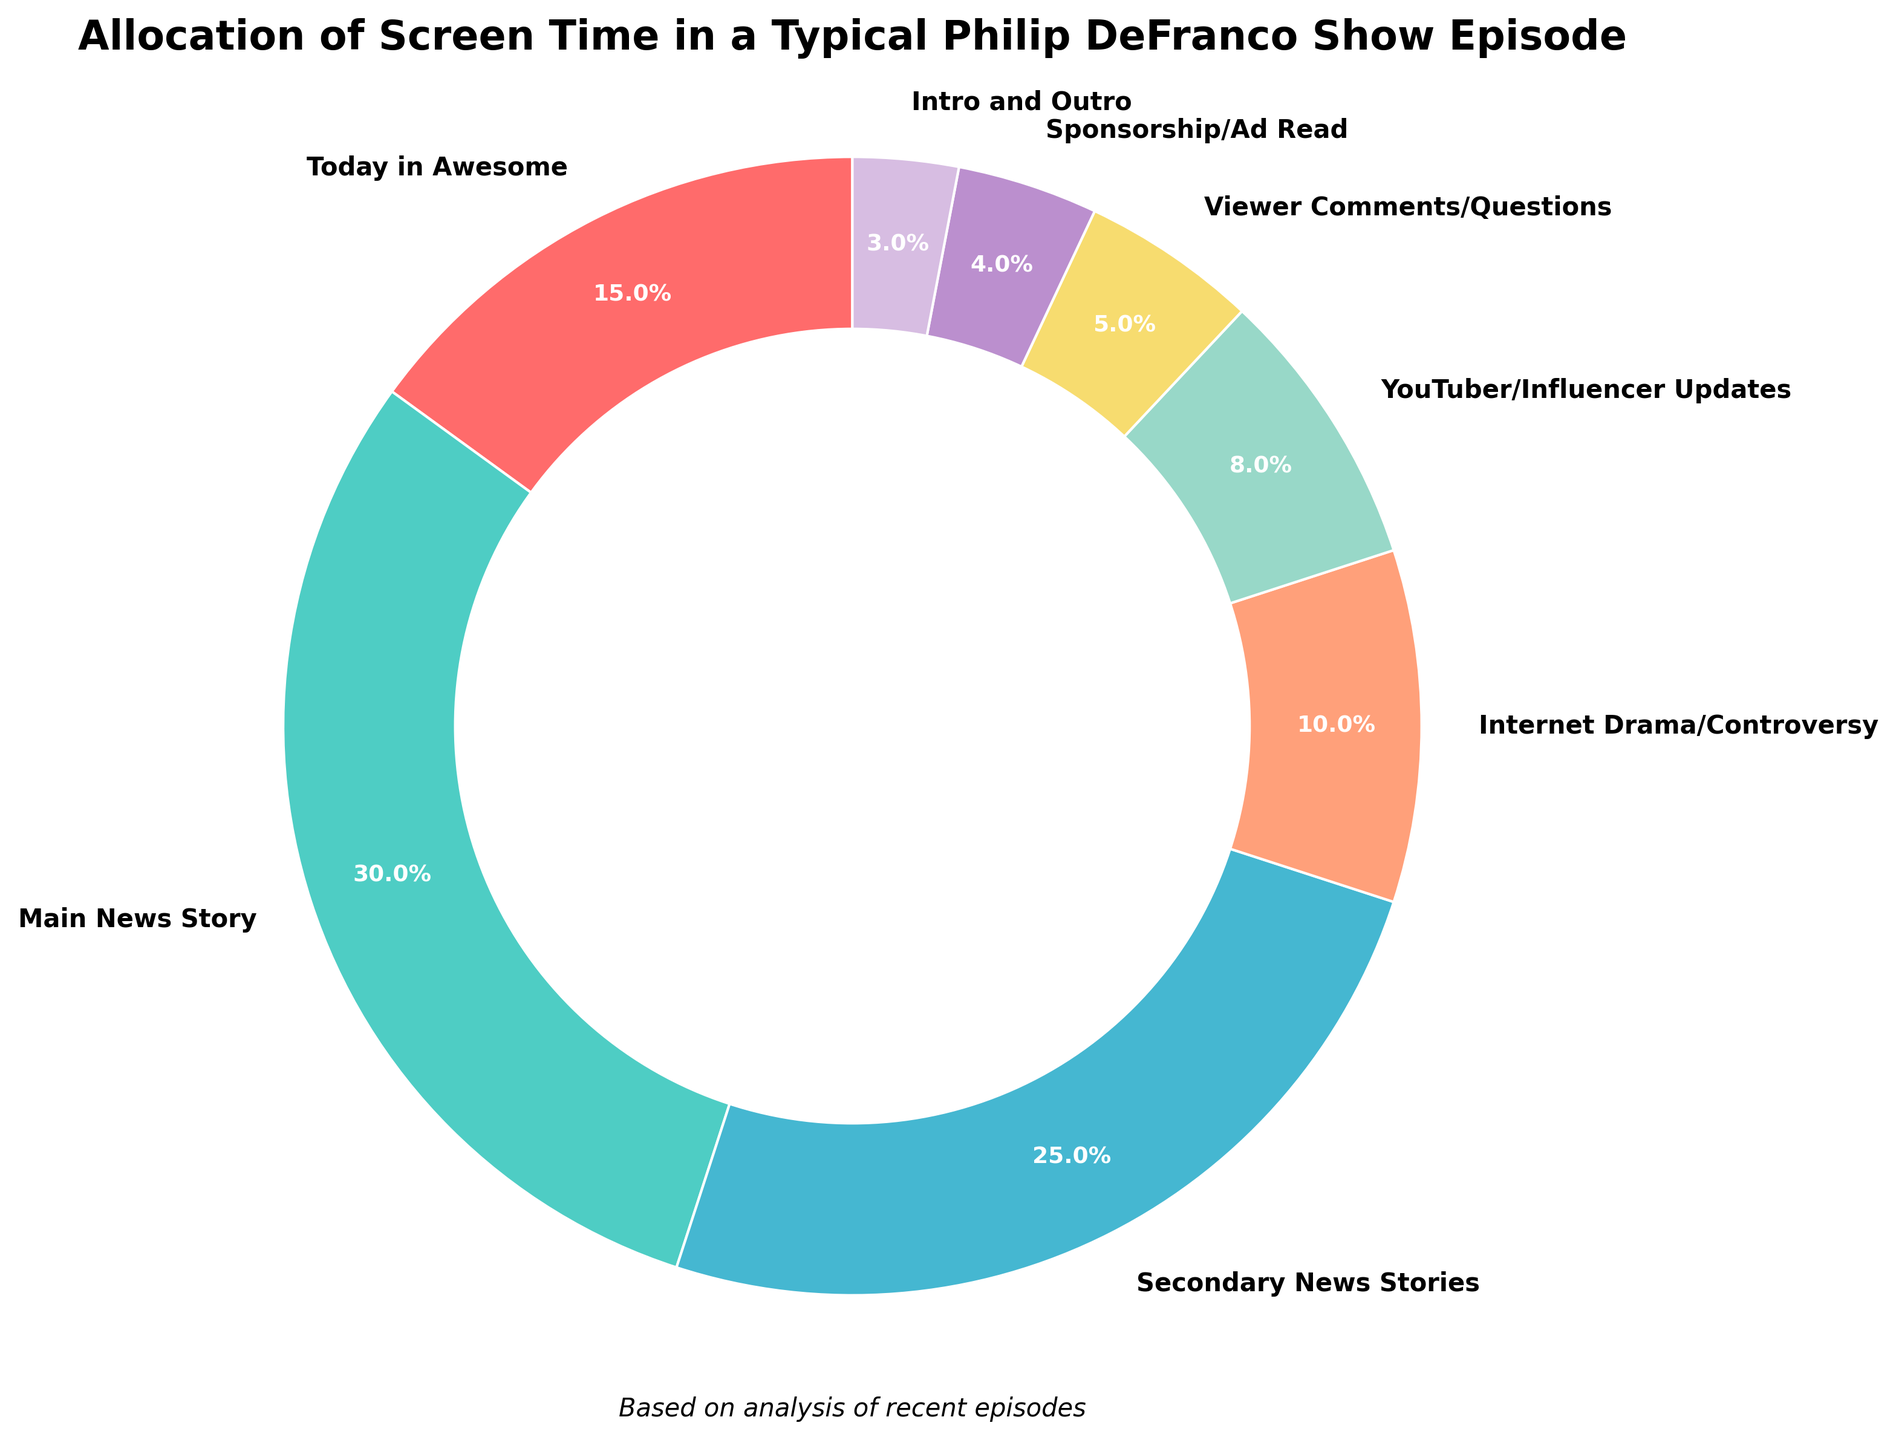What's the segment with the highest percentage of screen time? The pie chart shows the "Main News Story" with the largest segment, highlighted by both its size and the percentage value of 30%.
Answer: Main News Story Which segment has the least allocation of screen time? Observing the smallest segment in the pie chart, "Intro and Outro" is the section with the smallest percentage of 3%.
Answer: Intro and Outro What is the sum of screen time percentages for "Secondary News Stories" and "Internet Drama/Controversy"? The chart shows "Secondary News Stories" at 25% and "Internet Drama/Controversy" at 10%. Adding these values gives 25% + 10% = 35%.
Answer: 35% Which segment receives more screen time, "Today in Awesome" or "YouTuber/Influencer Updates"? Comparing the percentages, "Today in Awesome" has 15% while "YouTuber/Influencer Updates" has 8%, so "Today in Awesome" receives more screen time.
Answer: Today in Awesome How much more screen time does "Main News Story" have compared to "Viewer Comments/Questions"? "Main News Story" has 30% and "Viewer Comments/Questions" has 5%. The difference is 30% - 5% = 25%.
Answer: 25% Which color is used to represent "Today in Awesome"? The segment "Today in Awesome" is shown in the first color, which is a shade of red.
Answer: Red How many segments have a percentage value of less than 10%? Examining the chart, "Internet Drama/Controversy" (10%), "YouTuber/Influencer Updates" (8%), "Viewer Comments/Questions" (5%), "Sponsorship/Ad Read" (4%), and "Intro and Outro" (3%) have values less than 10%, so there are 4 segments.
Answer: 4 For which segment is the color purple used? The pie chart uses purple to mark the segment "Viewer Comments/Questions".
Answer: Viewer Comments/Questions What are the total percentages covered by non-news related segments? The non-news segments are: "Today in Awesome" (15%), "Internet Drama/Controversy" (10%), "YouTuber/Influencer Updates" (8%), "Viewer Comments/Questions" (5%), "Sponsorship/Ad Read" (4%), and "Intro and Outro" (3%). Summing these, 15% + 10% + 8% + 5% + 4% + 3% = 45%.
Answer: 45% 